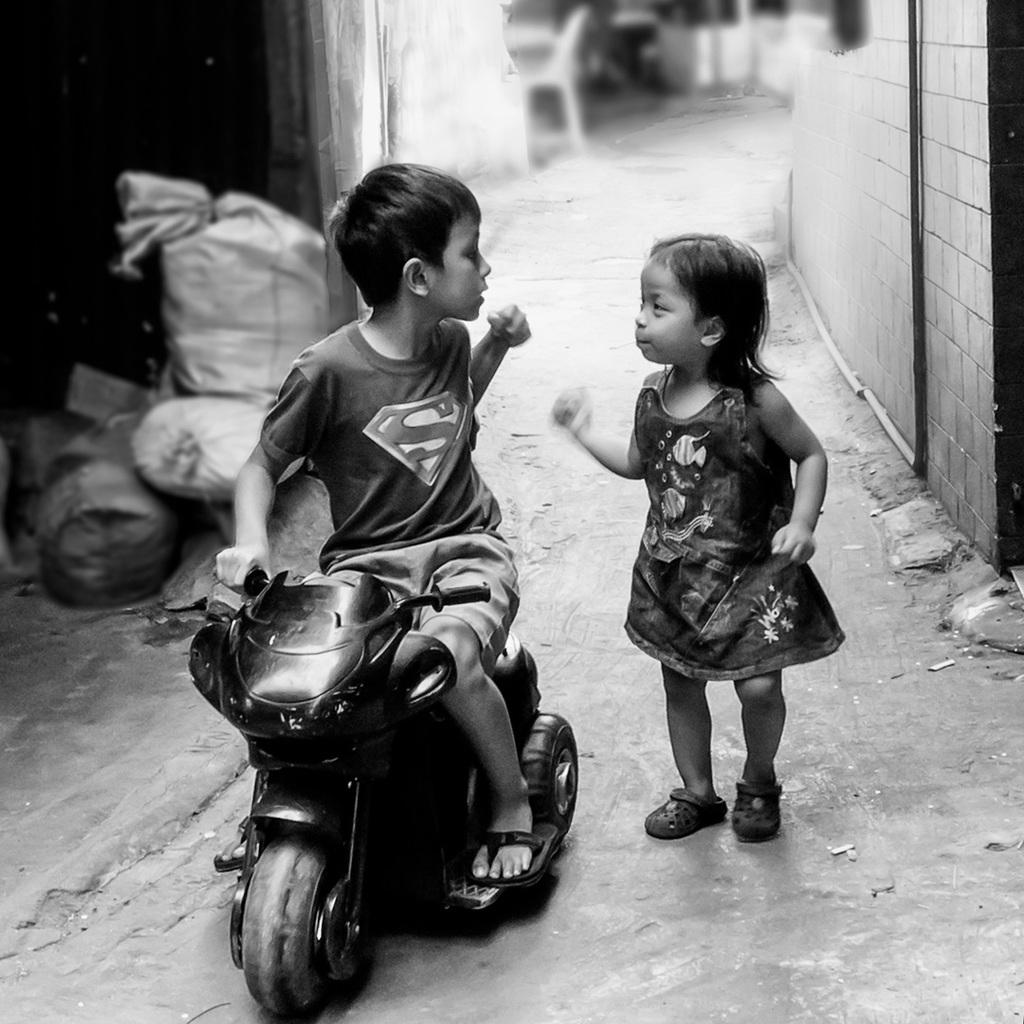How many children are in the image? There are two children in the image. What are the children doing in the image? The children are riding a bike in the image. Where is the bike located in the image? The bike is on the road in the image. What can be seen in the background of the image? There are bags visible in the background of the image. What type of chalk is being used to draw on the cloth in the image? There is no chalk or cloth present in the image; the children are riding a bike on the road. 